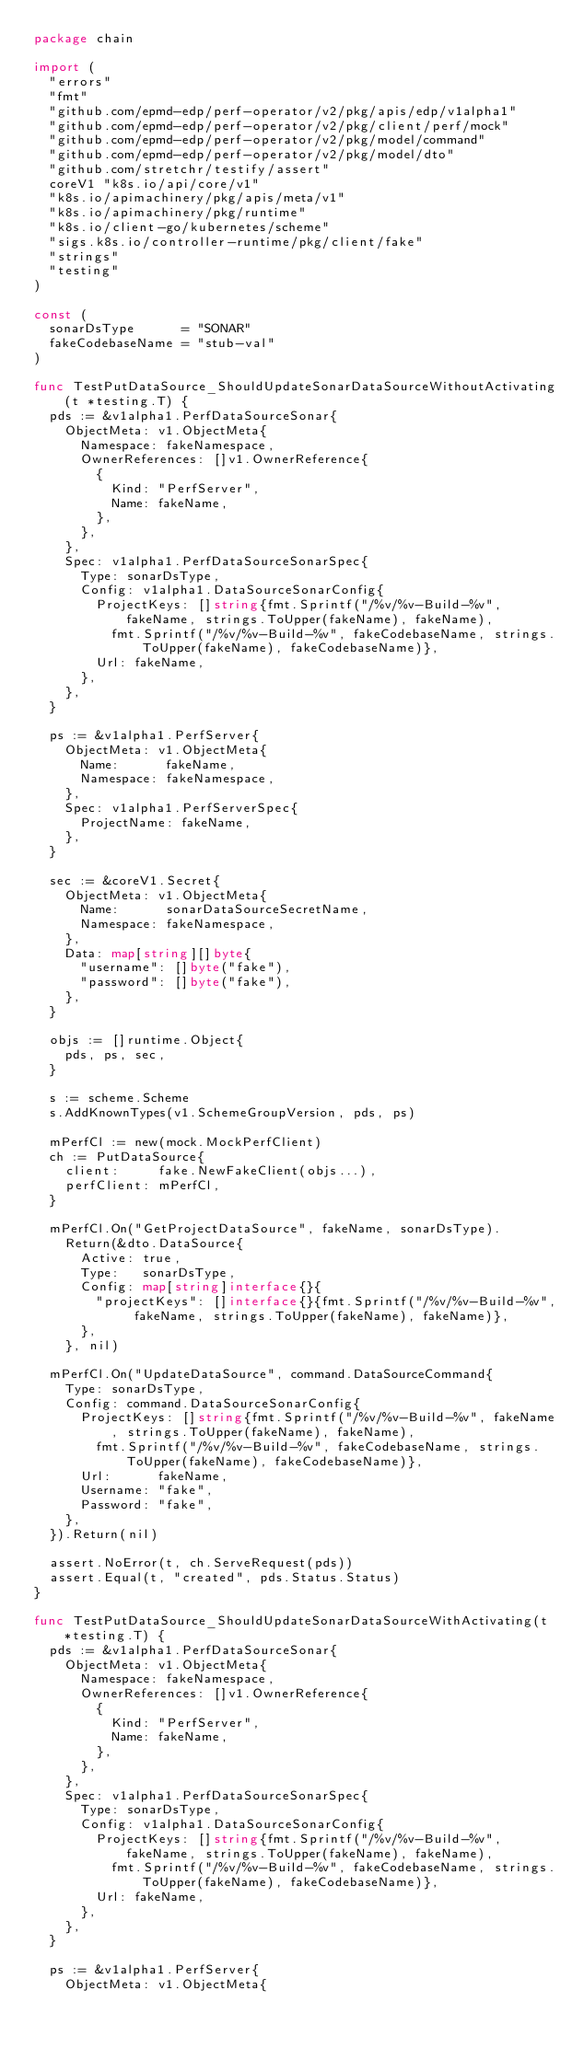Convert code to text. <code><loc_0><loc_0><loc_500><loc_500><_Go_>package chain

import (
	"errors"
	"fmt"
	"github.com/epmd-edp/perf-operator/v2/pkg/apis/edp/v1alpha1"
	"github.com/epmd-edp/perf-operator/v2/pkg/client/perf/mock"
	"github.com/epmd-edp/perf-operator/v2/pkg/model/command"
	"github.com/epmd-edp/perf-operator/v2/pkg/model/dto"
	"github.com/stretchr/testify/assert"
	coreV1 "k8s.io/api/core/v1"
	"k8s.io/apimachinery/pkg/apis/meta/v1"
	"k8s.io/apimachinery/pkg/runtime"
	"k8s.io/client-go/kubernetes/scheme"
	"sigs.k8s.io/controller-runtime/pkg/client/fake"
	"strings"
	"testing"
)

const (
	sonarDsType      = "SONAR"
	fakeCodebaseName = "stub-val"
)

func TestPutDataSource_ShouldUpdateSonarDataSourceWithoutActivating(t *testing.T) {
	pds := &v1alpha1.PerfDataSourceSonar{
		ObjectMeta: v1.ObjectMeta{
			Namespace: fakeNamespace,
			OwnerReferences: []v1.OwnerReference{
				{
					Kind: "PerfServer",
					Name: fakeName,
				},
			},
		},
		Spec: v1alpha1.PerfDataSourceSonarSpec{
			Type: sonarDsType,
			Config: v1alpha1.DataSourceSonarConfig{
				ProjectKeys: []string{fmt.Sprintf("/%v/%v-Build-%v", fakeName, strings.ToUpper(fakeName), fakeName),
					fmt.Sprintf("/%v/%v-Build-%v", fakeCodebaseName, strings.ToUpper(fakeName), fakeCodebaseName)},
				Url: fakeName,
			},
		},
	}

	ps := &v1alpha1.PerfServer{
		ObjectMeta: v1.ObjectMeta{
			Name:      fakeName,
			Namespace: fakeNamespace,
		},
		Spec: v1alpha1.PerfServerSpec{
			ProjectName: fakeName,
		},
	}

	sec := &coreV1.Secret{
		ObjectMeta: v1.ObjectMeta{
			Name:      sonarDataSourceSecretName,
			Namespace: fakeNamespace,
		},
		Data: map[string][]byte{
			"username": []byte("fake"),
			"password": []byte("fake"),
		},
	}

	objs := []runtime.Object{
		pds, ps, sec,
	}

	s := scheme.Scheme
	s.AddKnownTypes(v1.SchemeGroupVersion, pds, ps)

	mPerfCl := new(mock.MockPerfClient)
	ch := PutDataSource{
		client:     fake.NewFakeClient(objs...),
		perfClient: mPerfCl,
	}

	mPerfCl.On("GetProjectDataSource", fakeName, sonarDsType).
		Return(&dto.DataSource{
			Active: true,
			Type:   sonarDsType,
			Config: map[string]interface{}{
				"projectKeys": []interface{}{fmt.Sprintf("/%v/%v-Build-%v", fakeName, strings.ToUpper(fakeName), fakeName)},
			},
		}, nil)

	mPerfCl.On("UpdateDataSource", command.DataSourceCommand{
		Type: sonarDsType,
		Config: command.DataSourceSonarConfig{
			ProjectKeys: []string{fmt.Sprintf("/%v/%v-Build-%v", fakeName, strings.ToUpper(fakeName), fakeName),
				fmt.Sprintf("/%v/%v-Build-%v", fakeCodebaseName, strings.ToUpper(fakeName), fakeCodebaseName)},
			Url:      fakeName,
			Username: "fake",
			Password: "fake",
		},
	}).Return(nil)

	assert.NoError(t, ch.ServeRequest(pds))
	assert.Equal(t, "created", pds.Status.Status)
}

func TestPutDataSource_ShouldUpdateSonarDataSourceWithActivating(t *testing.T) {
	pds := &v1alpha1.PerfDataSourceSonar{
		ObjectMeta: v1.ObjectMeta{
			Namespace: fakeNamespace,
			OwnerReferences: []v1.OwnerReference{
				{
					Kind: "PerfServer",
					Name: fakeName,
				},
			},
		},
		Spec: v1alpha1.PerfDataSourceSonarSpec{
			Type: sonarDsType,
			Config: v1alpha1.DataSourceSonarConfig{
				ProjectKeys: []string{fmt.Sprintf("/%v/%v-Build-%v", fakeName, strings.ToUpper(fakeName), fakeName),
					fmt.Sprintf("/%v/%v-Build-%v", fakeCodebaseName, strings.ToUpper(fakeName), fakeCodebaseName)},
				Url: fakeName,
			},
		},
	}

	ps := &v1alpha1.PerfServer{
		ObjectMeta: v1.ObjectMeta{</code> 